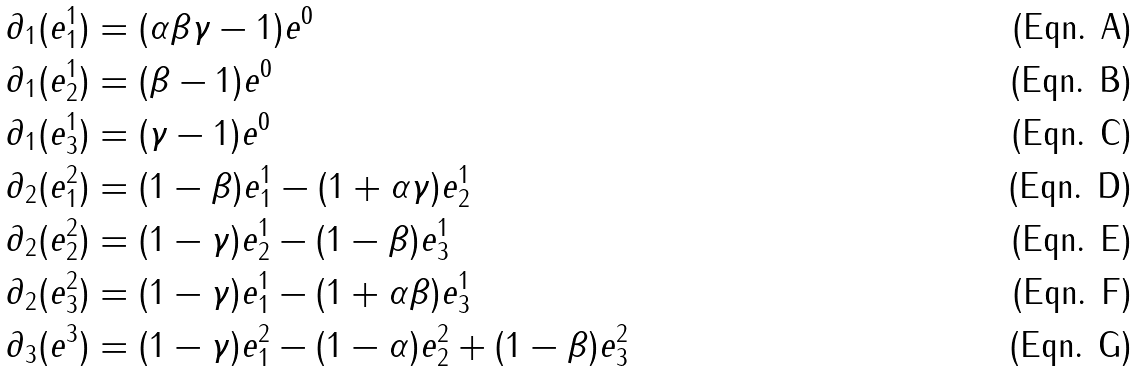<formula> <loc_0><loc_0><loc_500><loc_500>\partial _ { 1 } ( e _ { 1 } ^ { 1 } ) & = ( \alpha \beta \gamma - 1 ) e ^ { 0 } \\ \partial _ { 1 } ( e _ { 2 } ^ { 1 } ) & = ( \beta - 1 ) e ^ { 0 } \\ \partial _ { 1 } ( e _ { 3 } ^ { 1 } ) & = ( \gamma - 1 ) e ^ { 0 } \\ \partial _ { 2 } ( e _ { 1 } ^ { 2 } ) & = ( 1 - \beta ) e ^ { 1 } _ { 1 } - ( 1 + \alpha \gamma ) e ^ { 1 } _ { 2 } \\ \partial _ { 2 } ( e _ { 2 } ^ { 2 } ) & = ( 1 - \gamma ) e ^ { 1 } _ { 2 } - ( 1 - \beta ) e ^ { 1 } _ { 3 } \\ \partial _ { 2 } ( e _ { 3 } ^ { 2 } ) & = ( 1 - \gamma ) e ^ { 1 } _ { 1 } - ( 1 + \alpha \beta ) e ^ { 1 } _ { 3 } \\ \partial _ { 3 } ( e ^ { 3 } ) & = ( 1 - \gamma ) e ^ { 2 } _ { 1 } - ( 1 - \alpha ) e ^ { 2 } _ { 2 } + ( 1 - \beta ) e ^ { 2 } _ { 3 }</formula> 